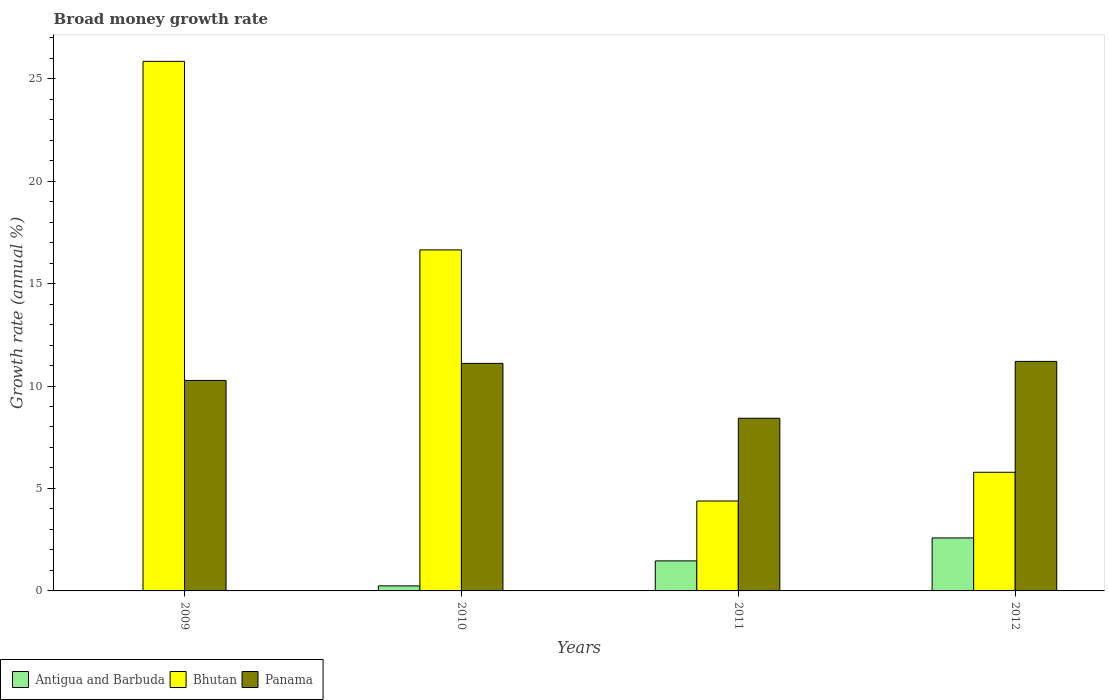How many different coloured bars are there?
Your response must be concise. 3. In how many cases, is the number of bars for a given year not equal to the number of legend labels?
Offer a very short reply. 1. What is the growth rate in Bhutan in 2009?
Offer a very short reply. 25.84. Across all years, what is the maximum growth rate in Bhutan?
Provide a short and direct response. 25.84. Across all years, what is the minimum growth rate in Panama?
Make the answer very short. 8.43. What is the total growth rate in Antigua and Barbuda in the graph?
Provide a short and direct response. 4.3. What is the difference between the growth rate in Bhutan in 2010 and that in 2011?
Your response must be concise. 12.26. What is the difference between the growth rate in Antigua and Barbuda in 2011 and the growth rate in Bhutan in 2009?
Offer a very short reply. -24.38. What is the average growth rate in Panama per year?
Make the answer very short. 10.25. In the year 2012, what is the difference between the growth rate in Bhutan and growth rate in Antigua and Barbuda?
Keep it short and to the point. 3.2. In how many years, is the growth rate in Antigua and Barbuda greater than 17 %?
Provide a short and direct response. 0. What is the ratio of the growth rate in Bhutan in 2011 to that in 2012?
Your response must be concise. 0.76. Is the growth rate in Bhutan in 2010 less than that in 2012?
Provide a short and direct response. No. What is the difference between the highest and the second highest growth rate in Panama?
Provide a succinct answer. 0.1. What is the difference between the highest and the lowest growth rate in Bhutan?
Your answer should be compact. 21.46. How many bars are there?
Your answer should be very brief. 11. Does the graph contain grids?
Keep it short and to the point. No. Where does the legend appear in the graph?
Make the answer very short. Bottom left. How are the legend labels stacked?
Give a very brief answer. Horizontal. What is the title of the graph?
Your answer should be very brief. Broad money growth rate. Does "Malawi" appear as one of the legend labels in the graph?
Offer a very short reply. No. What is the label or title of the Y-axis?
Offer a terse response. Growth rate (annual %). What is the Growth rate (annual %) in Bhutan in 2009?
Ensure brevity in your answer.  25.84. What is the Growth rate (annual %) in Panama in 2009?
Provide a short and direct response. 10.27. What is the Growth rate (annual %) of Antigua and Barbuda in 2010?
Your response must be concise. 0.25. What is the Growth rate (annual %) in Bhutan in 2010?
Offer a terse response. 16.64. What is the Growth rate (annual %) in Panama in 2010?
Provide a succinct answer. 11.1. What is the Growth rate (annual %) in Antigua and Barbuda in 2011?
Offer a very short reply. 1.47. What is the Growth rate (annual %) in Bhutan in 2011?
Provide a succinct answer. 4.39. What is the Growth rate (annual %) of Panama in 2011?
Offer a terse response. 8.43. What is the Growth rate (annual %) of Antigua and Barbuda in 2012?
Provide a succinct answer. 2.59. What is the Growth rate (annual %) in Bhutan in 2012?
Ensure brevity in your answer.  5.79. What is the Growth rate (annual %) in Panama in 2012?
Your answer should be compact. 11.2. Across all years, what is the maximum Growth rate (annual %) of Antigua and Barbuda?
Give a very brief answer. 2.59. Across all years, what is the maximum Growth rate (annual %) in Bhutan?
Give a very brief answer. 25.84. Across all years, what is the maximum Growth rate (annual %) in Panama?
Provide a short and direct response. 11.2. Across all years, what is the minimum Growth rate (annual %) in Bhutan?
Offer a terse response. 4.39. Across all years, what is the minimum Growth rate (annual %) of Panama?
Offer a terse response. 8.43. What is the total Growth rate (annual %) of Antigua and Barbuda in the graph?
Your response must be concise. 4.3. What is the total Growth rate (annual %) in Bhutan in the graph?
Ensure brevity in your answer.  52.67. What is the total Growth rate (annual %) of Panama in the graph?
Make the answer very short. 41.01. What is the difference between the Growth rate (annual %) of Bhutan in 2009 and that in 2010?
Provide a short and direct response. 9.2. What is the difference between the Growth rate (annual %) of Panama in 2009 and that in 2010?
Offer a terse response. -0.83. What is the difference between the Growth rate (annual %) of Bhutan in 2009 and that in 2011?
Offer a very short reply. 21.46. What is the difference between the Growth rate (annual %) of Panama in 2009 and that in 2011?
Offer a terse response. 1.85. What is the difference between the Growth rate (annual %) in Bhutan in 2009 and that in 2012?
Provide a succinct answer. 20.05. What is the difference between the Growth rate (annual %) of Panama in 2009 and that in 2012?
Ensure brevity in your answer.  -0.93. What is the difference between the Growth rate (annual %) of Antigua and Barbuda in 2010 and that in 2011?
Your answer should be compact. -1.22. What is the difference between the Growth rate (annual %) in Bhutan in 2010 and that in 2011?
Provide a short and direct response. 12.26. What is the difference between the Growth rate (annual %) of Panama in 2010 and that in 2011?
Offer a very short reply. 2.68. What is the difference between the Growth rate (annual %) in Antigua and Barbuda in 2010 and that in 2012?
Provide a succinct answer. -2.34. What is the difference between the Growth rate (annual %) of Bhutan in 2010 and that in 2012?
Provide a succinct answer. 10.85. What is the difference between the Growth rate (annual %) in Panama in 2010 and that in 2012?
Your answer should be compact. -0.1. What is the difference between the Growth rate (annual %) in Antigua and Barbuda in 2011 and that in 2012?
Your response must be concise. -1.12. What is the difference between the Growth rate (annual %) of Bhutan in 2011 and that in 2012?
Make the answer very short. -1.4. What is the difference between the Growth rate (annual %) of Panama in 2011 and that in 2012?
Give a very brief answer. -2.77. What is the difference between the Growth rate (annual %) of Bhutan in 2009 and the Growth rate (annual %) of Panama in 2010?
Your answer should be very brief. 14.74. What is the difference between the Growth rate (annual %) in Bhutan in 2009 and the Growth rate (annual %) in Panama in 2011?
Keep it short and to the point. 17.42. What is the difference between the Growth rate (annual %) of Bhutan in 2009 and the Growth rate (annual %) of Panama in 2012?
Offer a very short reply. 14.64. What is the difference between the Growth rate (annual %) in Antigua and Barbuda in 2010 and the Growth rate (annual %) in Bhutan in 2011?
Provide a succinct answer. -4.14. What is the difference between the Growth rate (annual %) of Antigua and Barbuda in 2010 and the Growth rate (annual %) of Panama in 2011?
Give a very brief answer. -8.18. What is the difference between the Growth rate (annual %) in Bhutan in 2010 and the Growth rate (annual %) in Panama in 2011?
Your response must be concise. 8.22. What is the difference between the Growth rate (annual %) in Antigua and Barbuda in 2010 and the Growth rate (annual %) in Bhutan in 2012?
Offer a very short reply. -5.54. What is the difference between the Growth rate (annual %) in Antigua and Barbuda in 2010 and the Growth rate (annual %) in Panama in 2012?
Your response must be concise. -10.96. What is the difference between the Growth rate (annual %) in Bhutan in 2010 and the Growth rate (annual %) in Panama in 2012?
Provide a short and direct response. 5.44. What is the difference between the Growth rate (annual %) in Antigua and Barbuda in 2011 and the Growth rate (annual %) in Bhutan in 2012?
Provide a short and direct response. -4.32. What is the difference between the Growth rate (annual %) of Antigua and Barbuda in 2011 and the Growth rate (annual %) of Panama in 2012?
Give a very brief answer. -9.74. What is the difference between the Growth rate (annual %) of Bhutan in 2011 and the Growth rate (annual %) of Panama in 2012?
Provide a succinct answer. -6.81. What is the average Growth rate (annual %) of Antigua and Barbuda per year?
Ensure brevity in your answer.  1.07. What is the average Growth rate (annual %) in Bhutan per year?
Provide a succinct answer. 13.17. What is the average Growth rate (annual %) of Panama per year?
Give a very brief answer. 10.25. In the year 2009, what is the difference between the Growth rate (annual %) of Bhutan and Growth rate (annual %) of Panama?
Ensure brevity in your answer.  15.57. In the year 2010, what is the difference between the Growth rate (annual %) of Antigua and Barbuda and Growth rate (annual %) of Bhutan?
Make the answer very short. -16.4. In the year 2010, what is the difference between the Growth rate (annual %) in Antigua and Barbuda and Growth rate (annual %) in Panama?
Provide a short and direct response. -10.86. In the year 2010, what is the difference between the Growth rate (annual %) in Bhutan and Growth rate (annual %) in Panama?
Offer a terse response. 5.54. In the year 2011, what is the difference between the Growth rate (annual %) in Antigua and Barbuda and Growth rate (annual %) in Bhutan?
Provide a succinct answer. -2.92. In the year 2011, what is the difference between the Growth rate (annual %) in Antigua and Barbuda and Growth rate (annual %) in Panama?
Give a very brief answer. -6.96. In the year 2011, what is the difference between the Growth rate (annual %) of Bhutan and Growth rate (annual %) of Panama?
Your response must be concise. -4.04. In the year 2012, what is the difference between the Growth rate (annual %) of Antigua and Barbuda and Growth rate (annual %) of Bhutan?
Provide a short and direct response. -3.2. In the year 2012, what is the difference between the Growth rate (annual %) of Antigua and Barbuda and Growth rate (annual %) of Panama?
Offer a terse response. -8.62. In the year 2012, what is the difference between the Growth rate (annual %) in Bhutan and Growth rate (annual %) in Panama?
Offer a terse response. -5.41. What is the ratio of the Growth rate (annual %) of Bhutan in 2009 to that in 2010?
Your answer should be very brief. 1.55. What is the ratio of the Growth rate (annual %) in Panama in 2009 to that in 2010?
Give a very brief answer. 0.93. What is the ratio of the Growth rate (annual %) of Bhutan in 2009 to that in 2011?
Provide a short and direct response. 5.89. What is the ratio of the Growth rate (annual %) of Panama in 2009 to that in 2011?
Keep it short and to the point. 1.22. What is the ratio of the Growth rate (annual %) in Bhutan in 2009 to that in 2012?
Provide a succinct answer. 4.46. What is the ratio of the Growth rate (annual %) of Panama in 2009 to that in 2012?
Your answer should be compact. 0.92. What is the ratio of the Growth rate (annual %) of Antigua and Barbuda in 2010 to that in 2011?
Your answer should be very brief. 0.17. What is the ratio of the Growth rate (annual %) in Bhutan in 2010 to that in 2011?
Your answer should be very brief. 3.79. What is the ratio of the Growth rate (annual %) of Panama in 2010 to that in 2011?
Provide a succinct answer. 1.32. What is the ratio of the Growth rate (annual %) of Antigua and Barbuda in 2010 to that in 2012?
Your answer should be very brief. 0.1. What is the ratio of the Growth rate (annual %) of Bhutan in 2010 to that in 2012?
Ensure brevity in your answer.  2.87. What is the ratio of the Growth rate (annual %) in Antigua and Barbuda in 2011 to that in 2012?
Provide a short and direct response. 0.57. What is the ratio of the Growth rate (annual %) in Bhutan in 2011 to that in 2012?
Offer a terse response. 0.76. What is the ratio of the Growth rate (annual %) of Panama in 2011 to that in 2012?
Ensure brevity in your answer.  0.75. What is the difference between the highest and the second highest Growth rate (annual %) of Antigua and Barbuda?
Offer a very short reply. 1.12. What is the difference between the highest and the second highest Growth rate (annual %) of Bhutan?
Your answer should be very brief. 9.2. What is the difference between the highest and the second highest Growth rate (annual %) of Panama?
Offer a very short reply. 0.1. What is the difference between the highest and the lowest Growth rate (annual %) of Antigua and Barbuda?
Make the answer very short. 2.59. What is the difference between the highest and the lowest Growth rate (annual %) in Bhutan?
Give a very brief answer. 21.46. What is the difference between the highest and the lowest Growth rate (annual %) in Panama?
Ensure brevity in your answer.  2.77. 